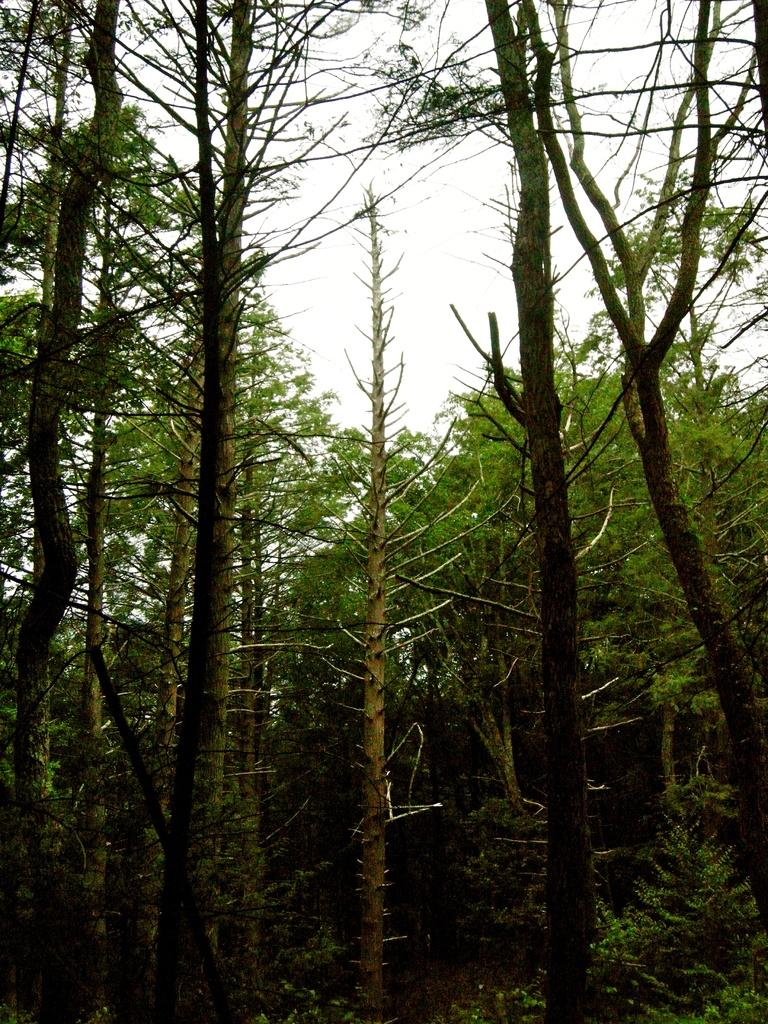What type of vegetation is in the foreground of the image? There are trees in the foreground of the image. What part of the natural environment is visible in the background of the image? The sky is visible in the background of the image. What type of sign can be seen hanging from the trees in the image? There is no sign present in the image; it only features trees in the foreground and the sky in the background. Can you tell me how many snakes are slithering through the trees in the image? There are no snakes present in the image; it only features trees in the foreground and the sky in the background. 